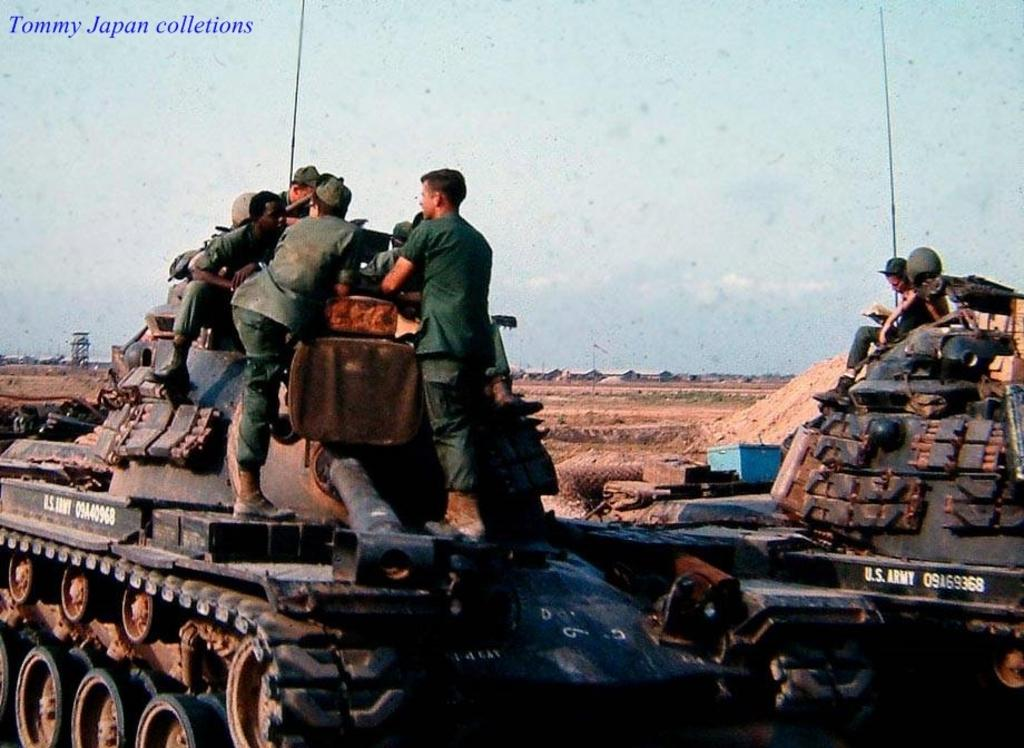What type of vehicles are present in the image? There are military tanks in the image. What are the people doing in relation to the tanks? People are standing and sitting on the tanks. What can be seen in the background of the image? There are tents and the sky visible in the background of the image. What type of laborer can be seen working on the seashore in the image? There is no laborer or seashore present in the image; it features military tanks with people standing and sitting on them, along with tents and the sky in the background. 